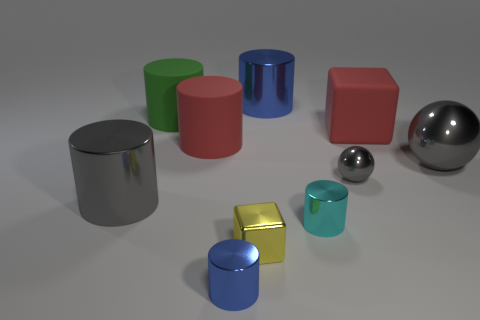Subtract all gray cylinders. How many cylinders are left? 5 Subtract all gray cylinders. How many cylinders are left? 5 Subtract 1 cylinders. How many cylinders are left? 5 Add 7 large red blocks. How many large red blocks exist? 8 Subtract 0 purple cylinders. How many objects are left? 10 Subtract all cylinders. How many objects are left? 4 Subtract all brown blocks. Subtract all yellow cylinders. How many blocks are left? 2 Subtract all purple balls. How many gray blocks are left? 0 Subtract all big blue metal cylinders. Subtract all yellow metal cubes. How many objects are left? 8 Add 8 big green cylinders. How many big green cylinders are left? 9 